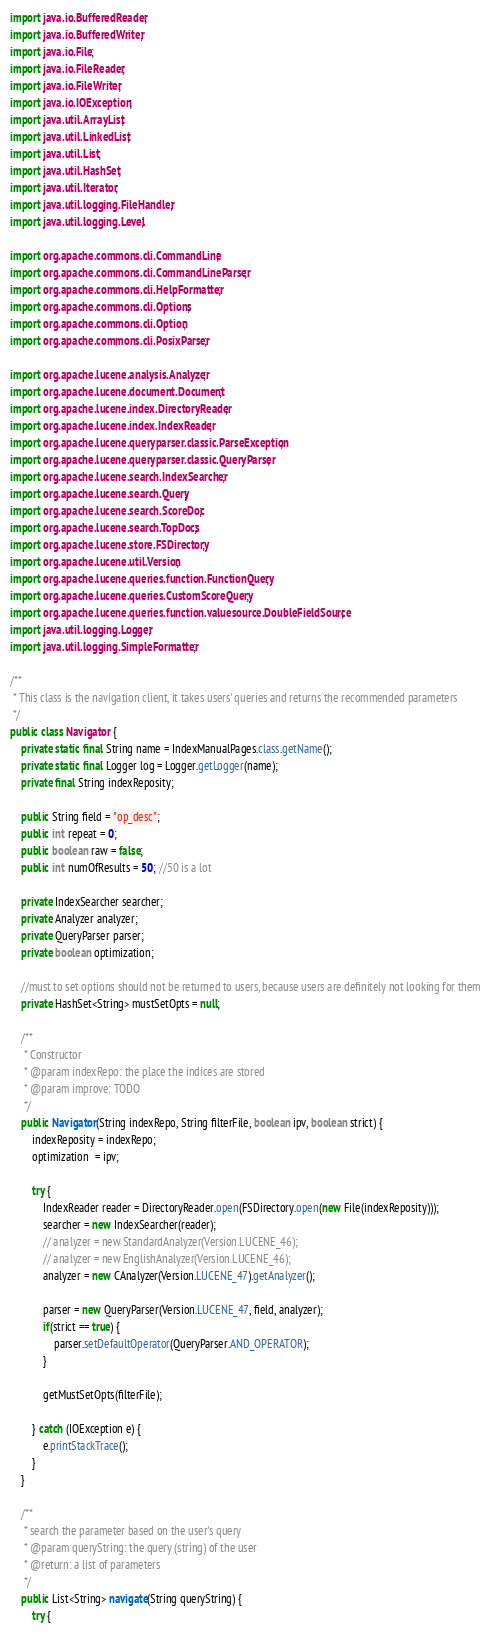Convert code to text. <code><loc_0><loc_0><loc_500><loc_500><_Java_>import java.io.BufferedReader;
import java.io.BufferedWriter;
import java.io.File;
import java.io.FileReader;
import java.io.FileWriter;
import java.io.IOException;
import java.util.ArrayList;
import java.util.LinkedList;
import java.util.List;
import java.util.HashSet;
import java.util.Iterator;
import java.util.logging.FileHandler;
import java.util.logging.Level;

import org.apache.commons.cli.CommandLine;
import org.apache.commons.cli.CommandLineParser;
import org.apache.commons.cli.HelpFormatter;
import org.apache.commons.cli.Options;
import org.apache.commons.cli.Option;
import org.apache.commons.cli.PosixParser;

import org.apache.lucene.analysis.Analyzer;
import org.apache.lucene.document.Document;
import org.apache.lucene.index.DirectoryReader;
import org.apache.lucene.index.IndexReader;
import org.apache.lucene.queryparser.classic.ParseException;
import org.apache.lucene.queryparser.classic.QueryParser;
import org.apache.lucene.search.IndexSearcher;
import org.apache.lucene.search.Query;
import org.apache.lucene.search.ScoreDoc;
import org.apache.lucene.search.TopDocs;
import org.apache.lucene.store.FSDirectory;
import org.apache.lucene.util.Version;
import org.apache.lucene.queries.function.FunctionQuery;
import org.apache.lucene.queries.CustomScoreQuery;
import org.apache.lucene.queries.function.valuesource.DoubleFieldSource;
import java.util.logging.Logger;
import java.util.logging.SimpleFormatter;

/**
 * This class is the navigation client, it takes users' queries and returns the recommended parameters
 */
public class Navigator {
	private static final String name = IndexManualPages.class.getName();
	private static final Logger log = Logger.getLogger(name);
	private final String indexReposity;

	public String field = "op_desc";
	public int repeat = 0;
	public boolean raw = false;
	public int numOfResults = 50; //50 is a lot

	private IndexSearcher searcher;
	private Analyzer analyzer;
	private QueryParser parser;
	private boolean optimization;

	//must to set options should not be returned to users, because users are definitely not looking for them
	private HashSet<String> mustSetOpts = null;
	
	/**
	 * Constructor
	 * @param indexRepo: the place the indices are stored
	 * @param improve: TODO
	 */
	public Navigator(String indexRepo, String filterFile, boolean ipv, boolean strict) {
		indexReposity = indexRepo;
		optimization  = ipv;

		try {
			IndexReader reader = DirectoryReader.open(FSDirectory.open(new File(indexReposity)));
			searcher = new IndexSearcher(reader);
			// analyzer = new StandardAnalyzer(Version.LUCENE_46);
			// analyzer = new EnglishAnalyzer(Version.LUCENE_46);
			analyzer = new CAnalyzer(Version.LUCENE_47).getAnalyzer();
			
			parser = new QueryParser(Version.LUCENE_47, field, analyzer);
			if(strict == true) {
				parser.setDefaultOperator(QueryParser.AND_OPERATOR);
			}
			
			getMustSetOpts(filterFile);
		
		} catch (IOException e) {
			e.printStackTrace();
		}
	}

	/**
	 * search the parameter based on the user's query
	 * @param queryString: the query (string) of the user
	 * @return: a list of parameters 
	 */
	public List<String> navigate(String queryString) {
		try {</code> 